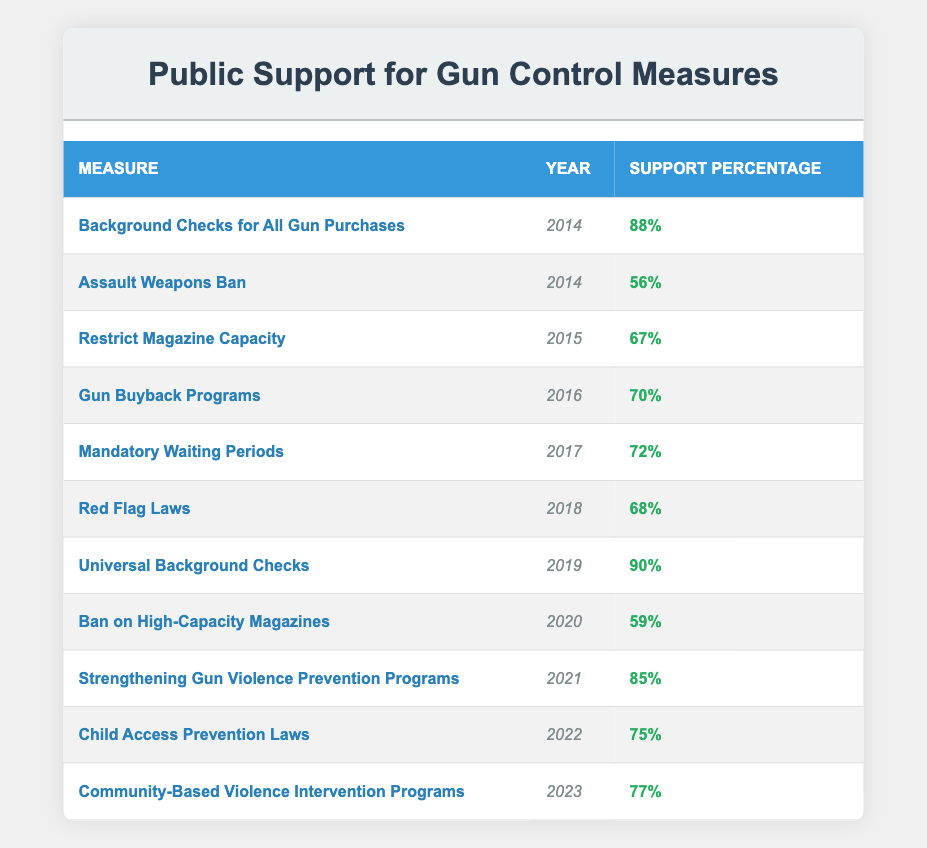What was the support percentage for "Background Checks for All Gun Purchases" in 2014? The table shows that the measure "Background Checks for All Gun Purchases" had a support percentage of 88 in the year 2014.
Answer: 88 Which gun control measure had the highest support in 2019? By examining the table, the measure "Universal Background Checks" had the highest support percentage of 90 in 2019.
Answer: 90 What is the average support percentage of gun control measures from 2016 to 2022? The support percentages from 2016 to 2022 are 70, 72, 68, 85, and 75. Adding these gives 70 + 72 + 68 + 85 + 75 = 370. There are 5 measures, so the average is 370/5 = 74.
Answer: 74 Has public support for the "Assault Weapons Ban" increased since 2014? In the table, the support percentage for the "Assault Weapons Ban" in 2014 was 56, and there are no subsequent data points for this measure to indicate a change. Therefore, we cannot determine if support has increased after 2014.
Answer: No What was the support for "Child Access Prevention Laws" compared to "Community-Based Violence Intervention Programs"? The support for "Child Access Prevention Laws" in 2022 was 75, while "Community-Based Violence Intervention Programs" in 2023 had support of 77. Thus, 77 - 75 = 2 indicates that the latter had 2 percent more support.
Answer: 2 percent more support for Community-Based Violence Intervention Programs Which gun control measure consistently had over 70% support from 2016 to 2022? Reviewing the table, the measures from 2016 to 2022 have the following support percentages: Gun Buyback Programs (70), Mandatory Waiting Periods (72), Red Flag Laws (68), Strengthening Gun Violence Prevention Programs (85), and Child Access Prevention Laws (75). The measures "Mandatory Waiting Periods" and "Strengthening Gun Violence Prevention Programs" are consistently above 70%.
Answer: Mandatory Waiting Periods and Strengthening Gun Violence Prevention Programs 